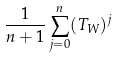Convert formula to latex. <formula><loc_0><loc_0><loc_500><loc_500>\frac { 1 } { n + 1 } \sum _ { j = 0 } ^ { n } ( T _ { W } ) ^ { j }</formula> 